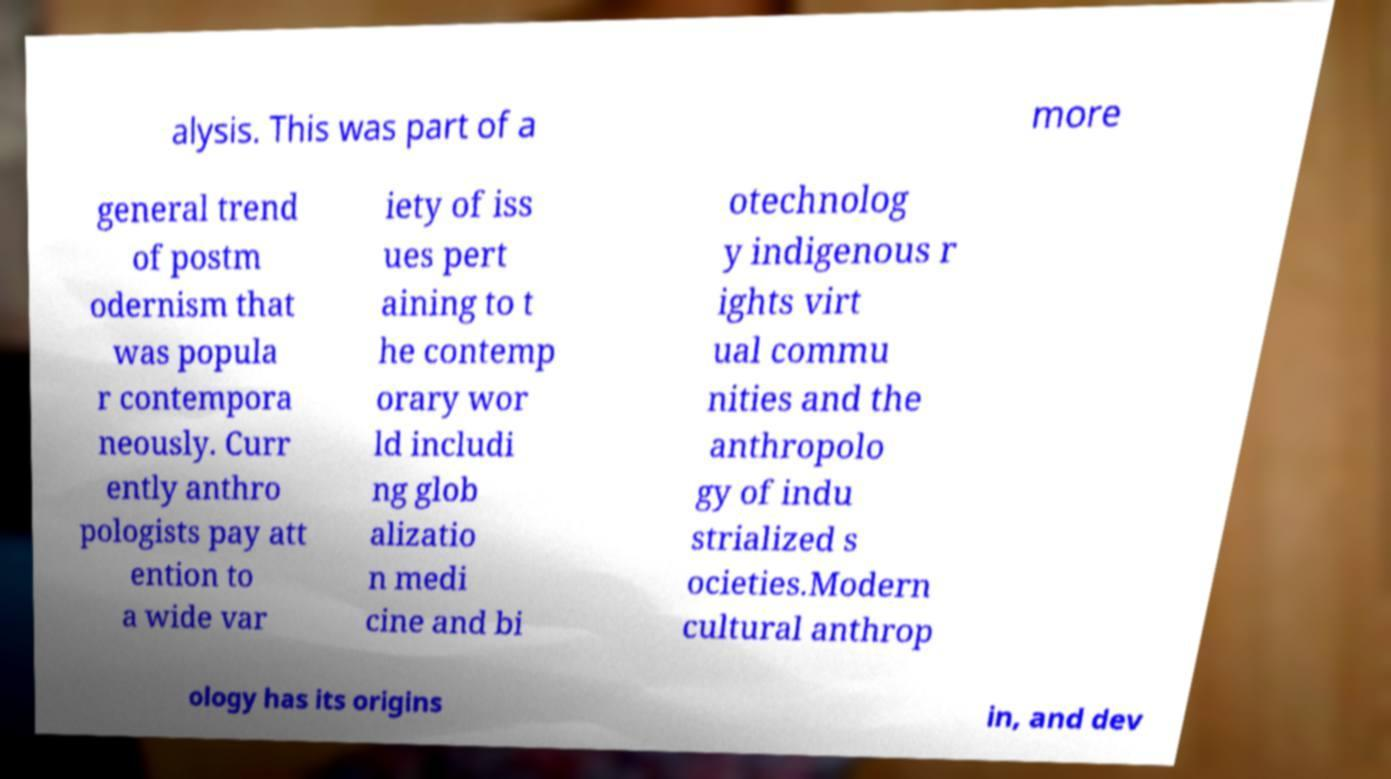Can you accurately transcribe the text from the provided image for me? alysis. This was part of a more general trend of postm odernism that was popula r contempora neously. Curr ently anthro pologists pay att ention to a wide var iety of iss ues pert aining to t he contemp orary wor ld includi ng glob alizatio n medi cine and bi otechnolog y indigenous r ights virt ual commu nities and the anthropolo gy of indu strialized s ocieties.Modern cultural anthrop ology has its origins in, and dev 